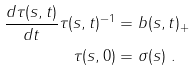Convert formula to latex. <formula><loc_0><loc_0><loc_500><loc_500>\frac { d \tau ( s , t ) } { d t } \tau ( s , t ) ^ { - 1 } & = b ( s , t ) _ { + } \\ \tau ( s , 0 ) & = \sigma ( s ) \ .</formula> 